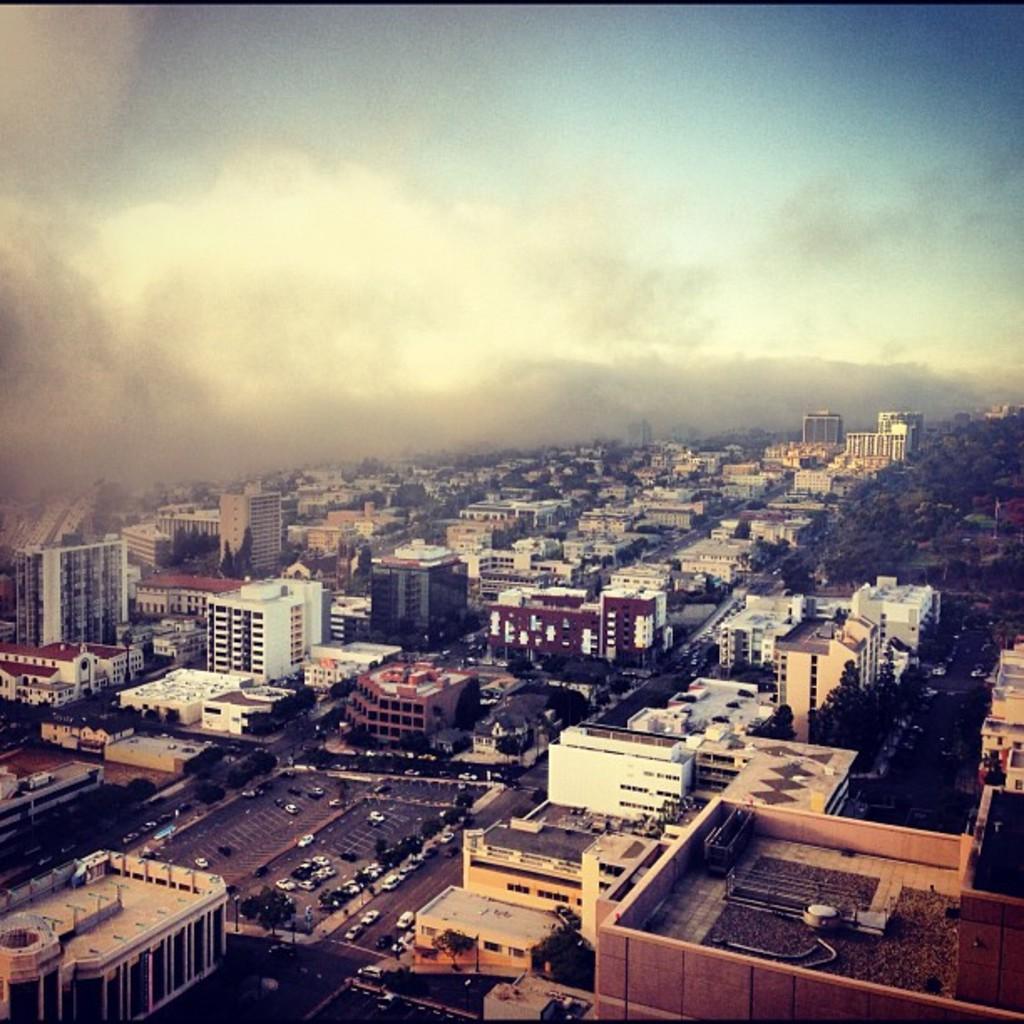Can you describe this image briefly? In the image we can see there are many buildings, trees and vehicles. Here we can see the road, smokey and the sky. 